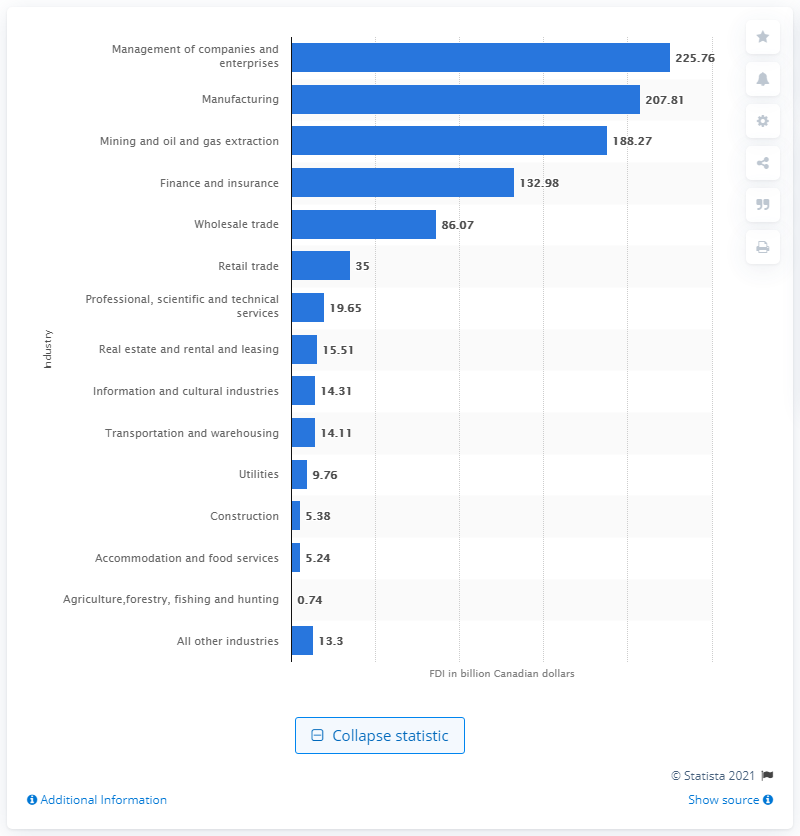Identify some key points in this picture. In 2019, the value of the manufacturing industry in Canada was 207.81 dollars. In 2019, the value of the management of companies and enterprises in Canadian dollars was 225.76. 